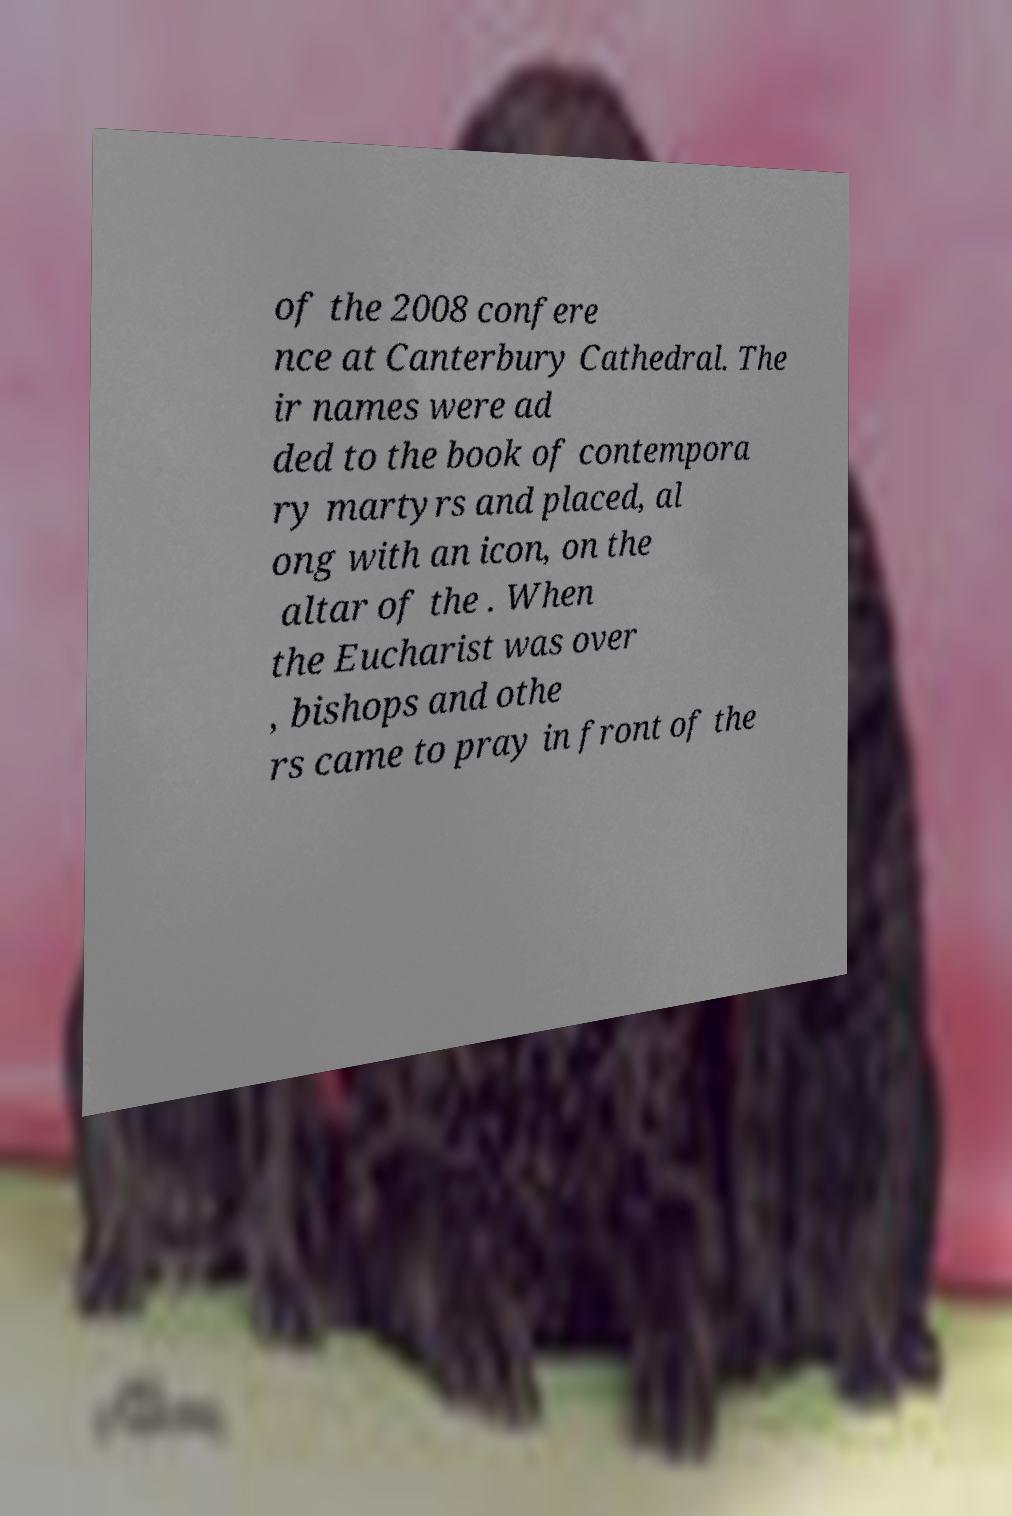For documentation purposes, I need the text within this image transcribed. Could you provide that? of the 2008 confere nce at Canterbury Cathedral. The ir names were ad ded to the book of contempora ry martyrs and placed, al ong with an icon, on the altar of the . When the Eucharist was over , bishops and othe rs came to pray in front of the 